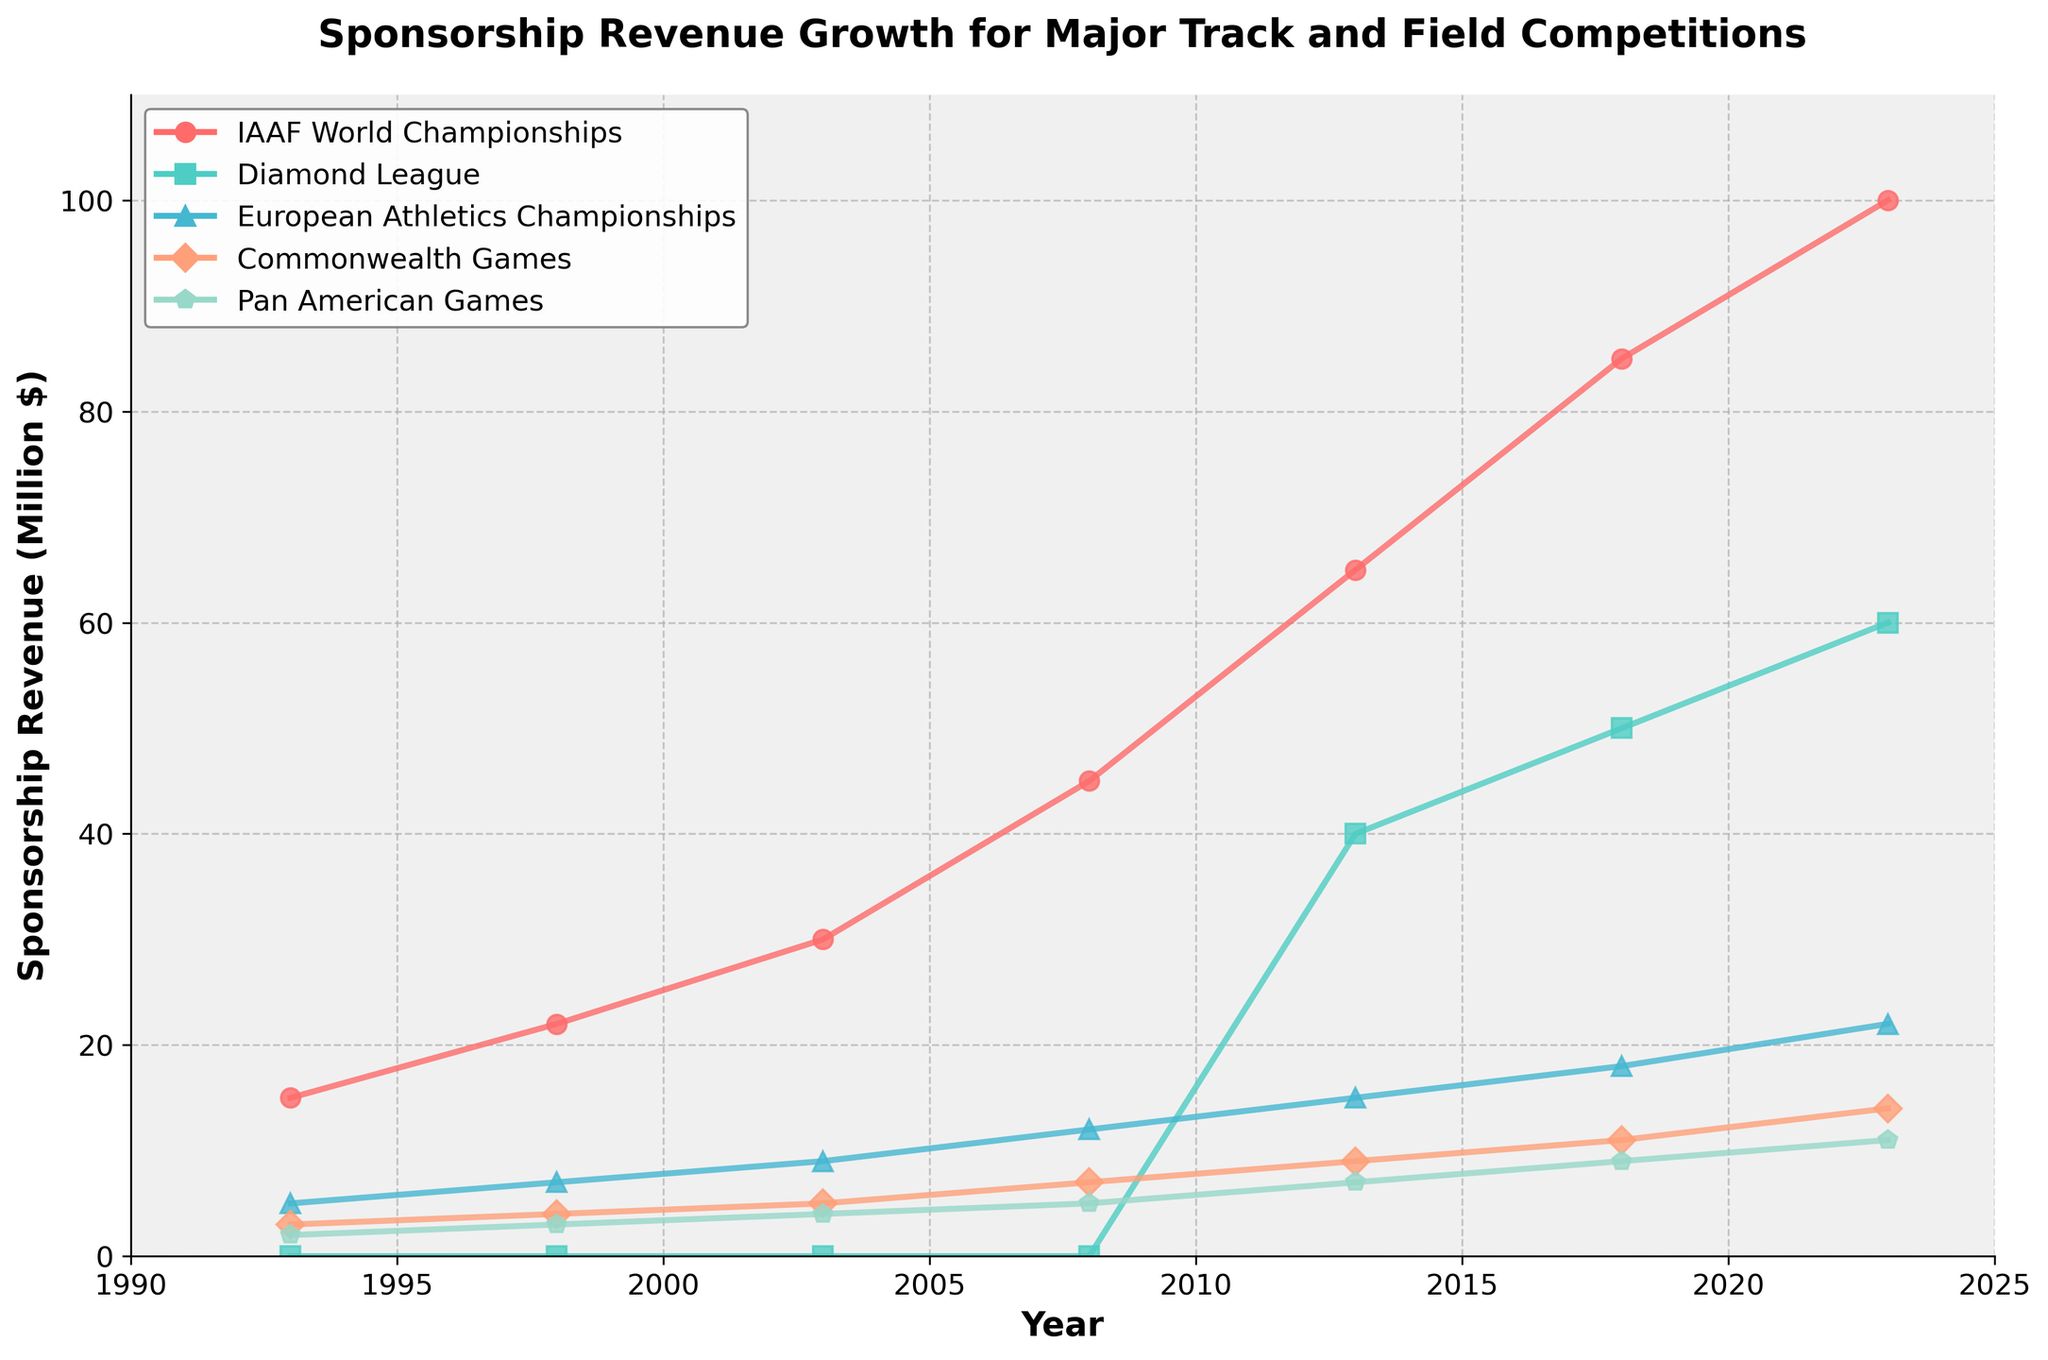What year did the IAAF World Championships surpass $50 million in sponsorship revenue? The IAAF World Championships are represented by the red line. It crosses the $50 million mark between 2008 and 2013. By looking at the data points, the year is specifically 2013.
Answer: 2013 Which competition had the highest sponsorship revenue in 2013? The chart shows the sponsorship revenue for all competitions. In 2013, the red line (IAAF World Championships) is higher than all other lines, indicating it had the highest revenue.
Answer: IAAF World Championships Between 2013 and 2023, which event experienced the largest increase in sponsorship revenue? Examining the lines from 2013 to 2023, the IAAF World Championships (red line) increased from $65 million to $100 million, which is a growth of $35 million. Other events show smaller growths.
Answer: IAAF World Championships When did the Diamond League first show significant sponsorship revenue? The Diamond League (green line) starts showing sponsorship revenue in 2013, as there is no data for it before that year.
Answer: 2013 Calculate the total sponsorship revenue for all competitions combined in the year 2023. Sum up the sponsorship revenues for all events in 2023: IAAF World Championships (100) + Diamond League (60) + European Athletics Championships (22) + Commonwealth Games (14) + Pan American Games (11). The total is 100 + 60 + 22 + 14 + 11 = 207 million dollars.
Answer: 207 million dollars Which event had the slowest revenue growth from 1993 to 2023? Comparing the overall growth of each event from their starting points in 1993 to 2023, the Pan American Games (blue line) went from $2 million to $11 million, which is a growth of $9 million, the smallest among all events.
Answer: Pan American Games How does the sponsorship revenue of the European Athletics Championships in 2018 compare to that in 2008? The chart shows that in 2008, the European Athletics Championships (orange line) had $12 million, and in 2018, it had $18 million. The increase is $18 - $12 = $6 million.
Answer: $6 million increase Which two events had nearly equal sponsorship revenue in 2013? Observing the chart in 2013, both the Commonwealth Games (purple line) and the Pan American Games (blue line) have similar sponsorship revenues. The Commonwealth Games are at $9 million, and the Pan American Games are at $7 million.
Answer: Commonwealth Games and Pan American Games What is the average sponsorship revenue for the Diamond League from 2013 to 2023? The sponsorship revenues for the Diamond League are in 2013 ($40 million), 2018 ($50 million), and 2023 ($60 million). The average is (40 + 50 + 60) / 3 = 150 / 3 = 50 million dollars.
Answer: 50 million dollars 